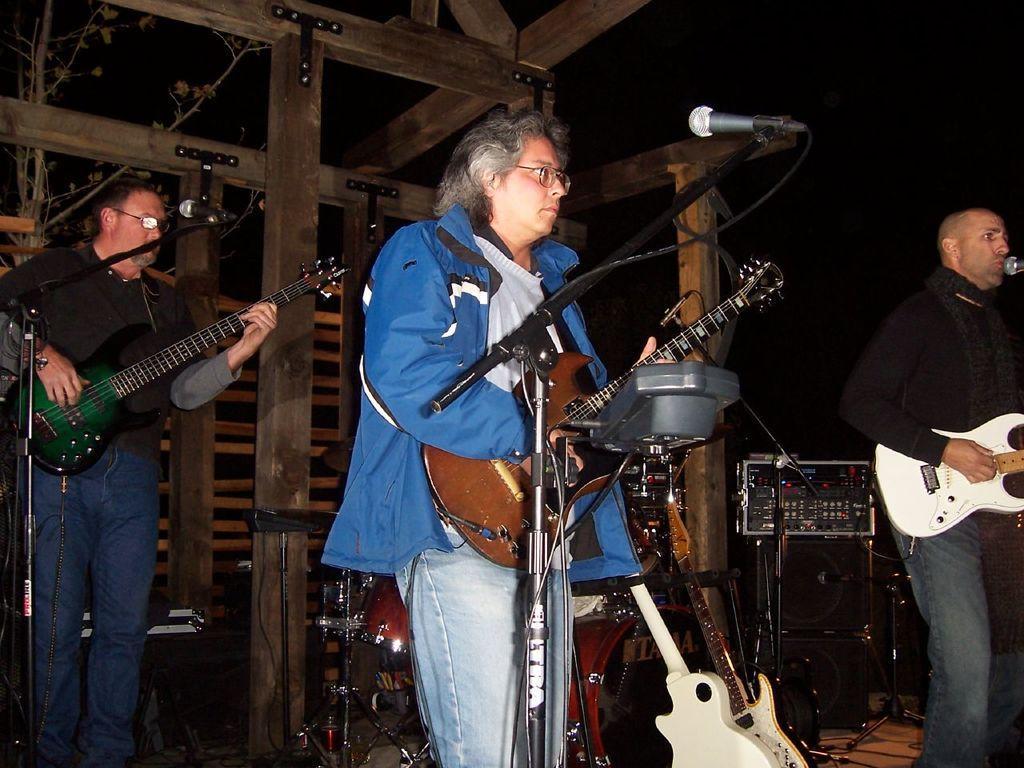Could you give a brief overview of what you see in this image? In this picture there are three men playing musical instruments. Towards the left there is a man wearing a black t shirt and blue jeans and playing a guitar, before him there is a mike. A man in the center, he is wearing a blue jacket, blue jeans and playing a guitar, before him there is a mike. Towards the right there is man wearing a black t shirt and blue jeans and black scarf and he is playing a guitar. In the background there are musical instruments, devices and wooden pillars. 